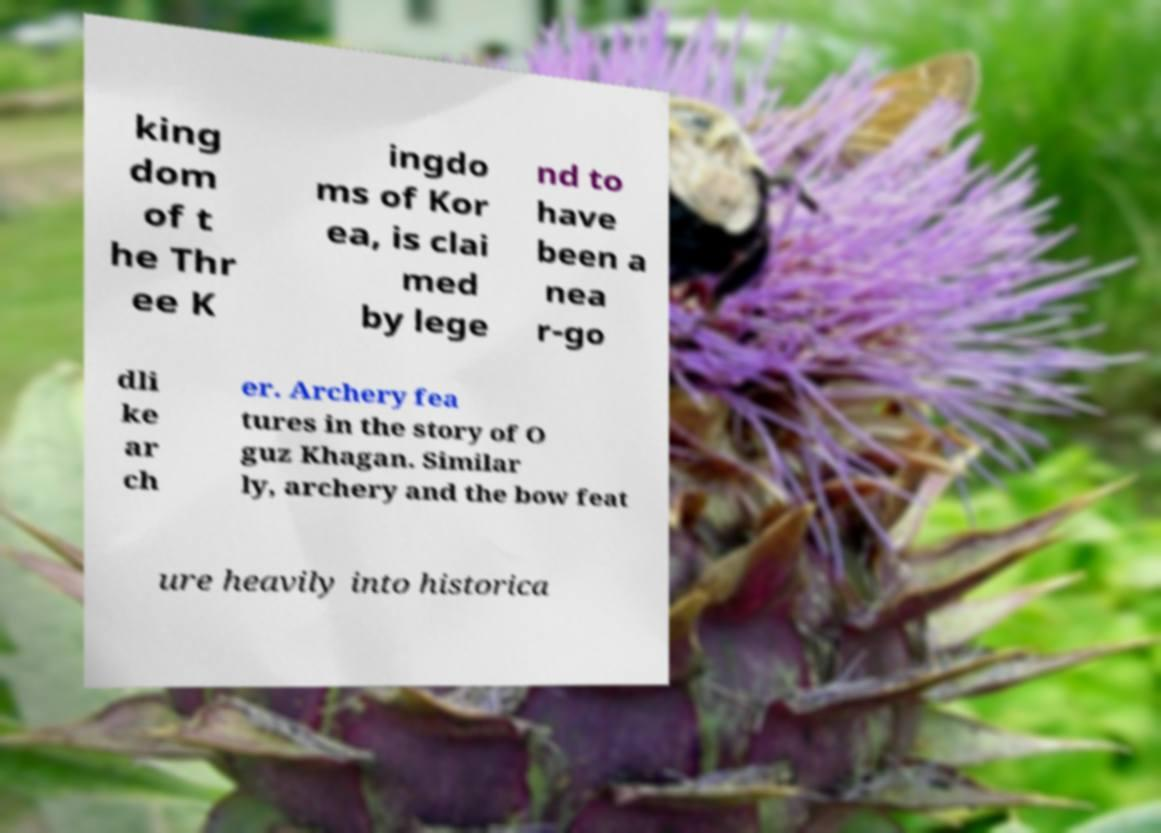Can you read and provide the text displayed in the image?This photo seems to have some interesting text. Can you extract and type it out for me? king dom of t he Thr ee K ingdo ms of Kor ea, is clai med by lege nd to have been a nea r-go dli ke ar ch er. Archery fea tures in the story of O guz Khagan. Similar ly, archery and the bow feat ure heavily into historica 